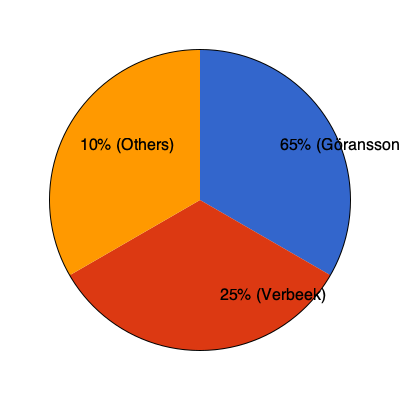The pie chart above shows the percentage of successful first serves for André Göransson, Sem Verbeek, and other players in a recent tennis tournament. What is the ratio of Göransson's successful first serves to Verbeek's, expressed as a simplified fraction? To find the ratio of Göransson's successful first serves to Verbeek's, we need to follow these steps:

1. Identify the percentages:
   - Göransson: 65%
   - Verbeek: 25%

2. Convert percentages to a ratio:
   Göransson : Verbeek = 65 : 25

3. Simplify the ratio:
   - Divide both numbers by their greatest common divisor (GCD).
   - GCD of 65 and 25 is 5.
   
   $\frac{65}{5} : \frac{25}{5} = 13 : 5$

Therefore, the simplified ratio of Göransson's successful first serves to Verbeek's is 13:5.
Answer: 13:5 